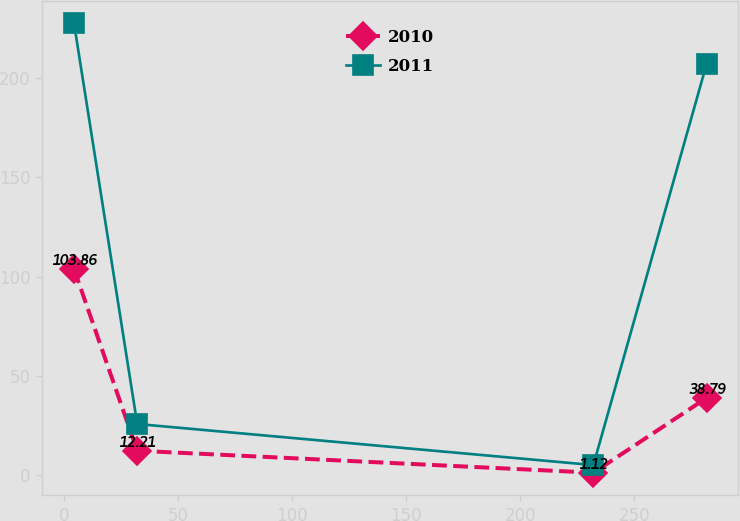<chart> <loc_0><loc_0><loc_500><loc_500><line_chart><ecel><fcel>2010<fcel>2011<nl><fcel>4.24<fcel>103.86<fcel>227.78<nl><fcel>31.99<fcel>12.21<fcel>25.68<nl><fcel>232.12<fcel>1.12<fcel>4.97<nl><fcel>281.76<fcel>38.79<fcel>207.07<nl></chart> 